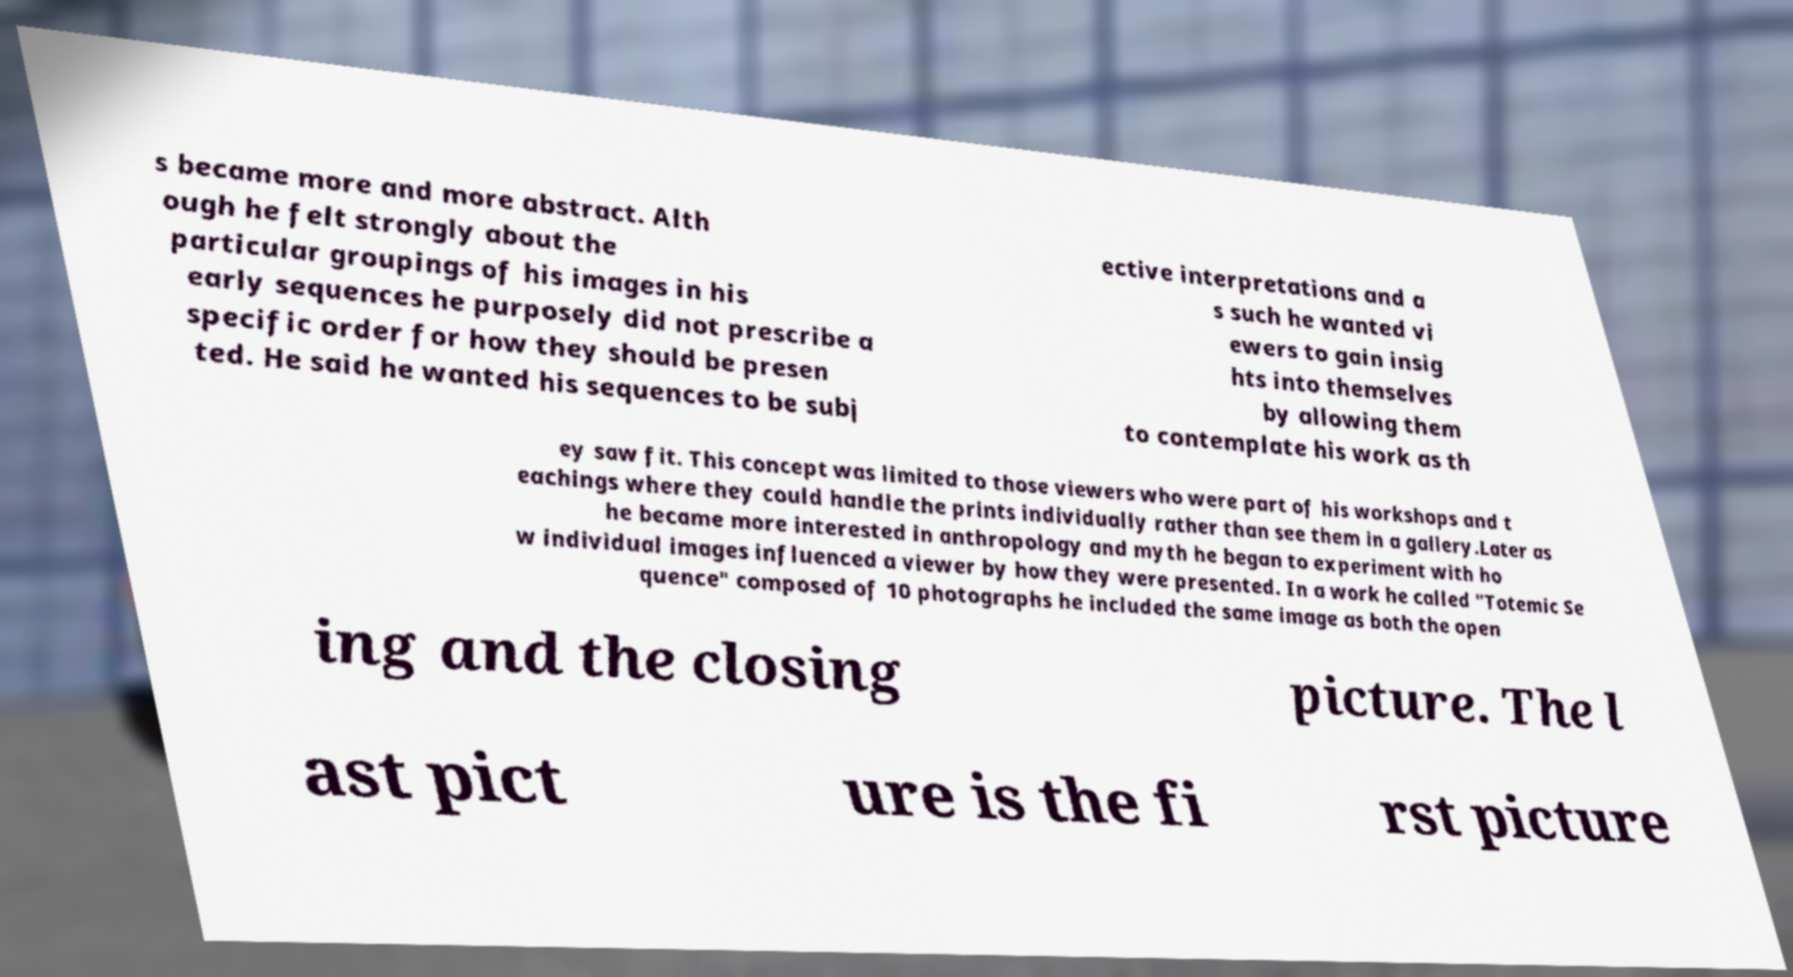Can you accurately transcribe the text from the provided image for me? s became more and more abstract. Alth ough he felt strongly about the particular groupings of his images in his early sequences he purposely did not prescribe a specific order for how they should be presen ted. He said he wanted his sequences to be subj ective interpretations and a s such he wanted vi ewers to gain insig hts into themselves by allowing them to contemplate his work as th ey saw fit. This concept was limited to those viewers who were part of his workshops and t eachings where they could handle the prints individually rather than see them in a gallery.Later as he became more interested in anthropology and myth he began to experiment with ho w individual images influenced a viewer by how they were presented. In a work he called "Totemic Se quence" composed of 10 photographs he included the same image as both the open ing and the closing picture. The l ast pict ure is the fi rst picture 